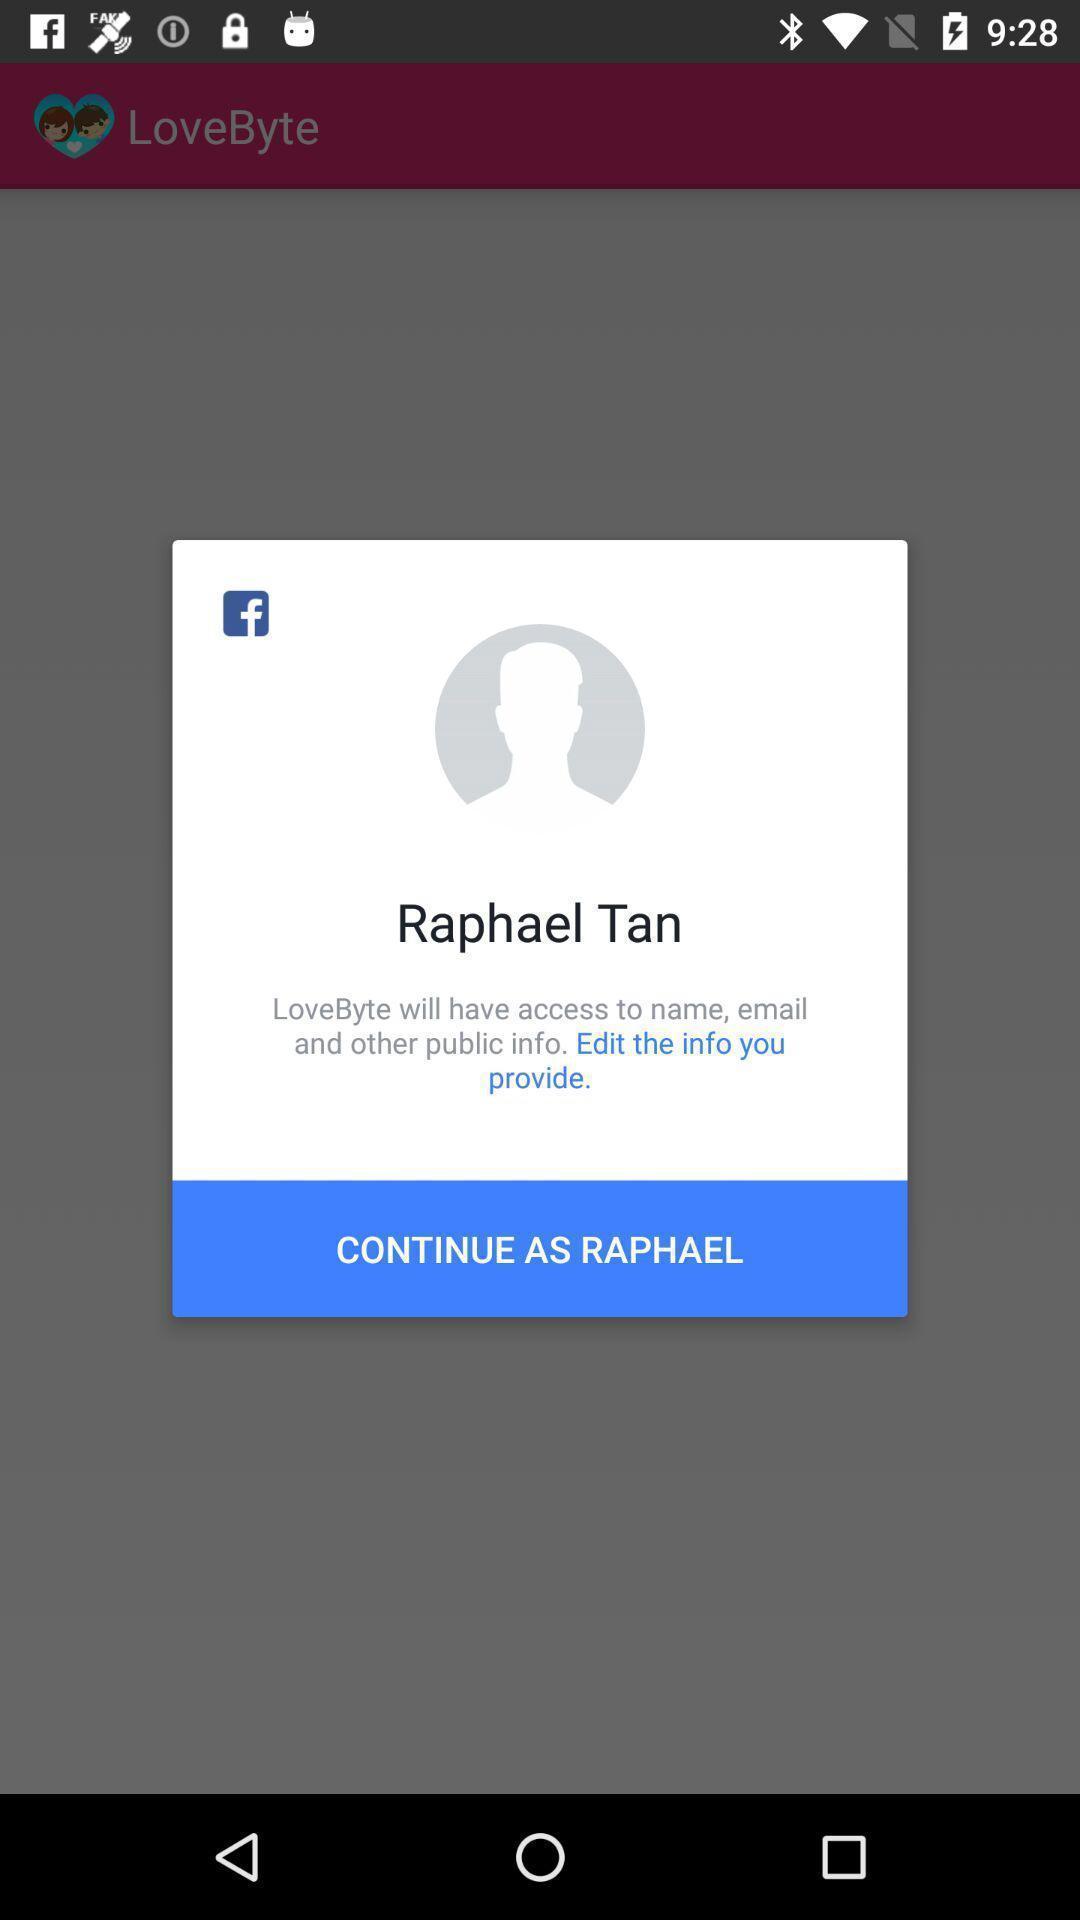Summarize the information in this screenshot. Pop-up displaying the social app profile. 